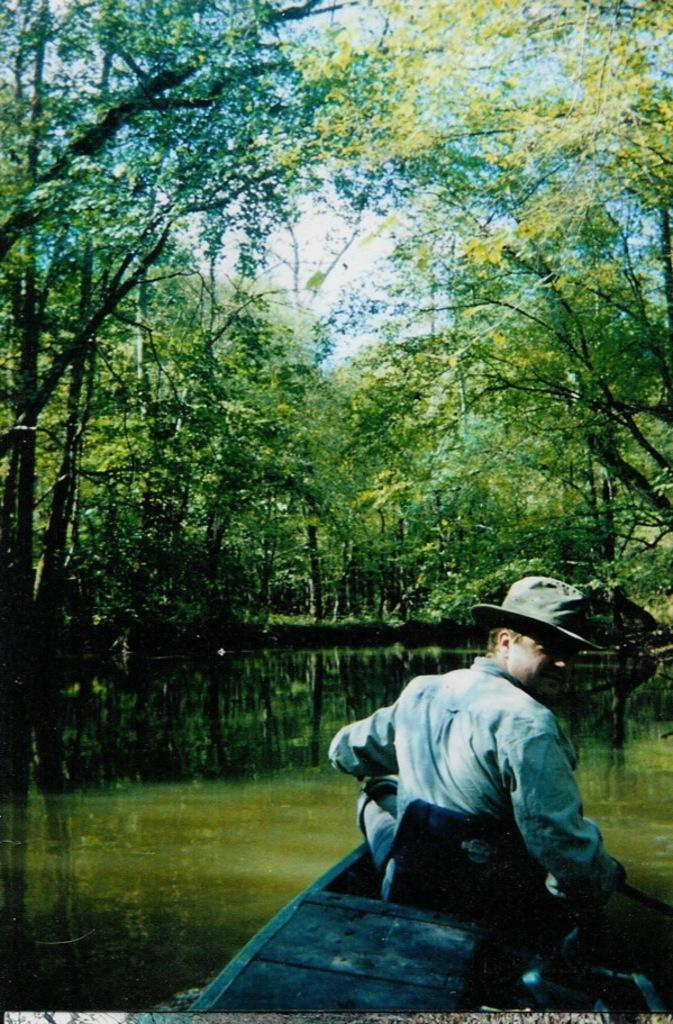What is the person in the image doing? The person is sitting on a boat in the image. Where is the boat located? The boat is on the water. What can be seen in the background of the image? There are trees in the background of the image. What is the color of the trees? The trees are green. What is the color of the sky in the image? The sky is blue and white. What type of oven can be seen in the image? There is no oven present in the image. How many stockings are hanging from the trees in the image? There are no stockings hanging from the trees in the image. 